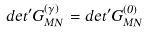<formula> <loc_0><loc_0><loc_500><loc_500>d e t ^ { \prime } G _ { M N } ^ { ( \gamma ) } = d e t ^ { \prime } G _ { M N } ^ { ( 0 ) }</formula> 